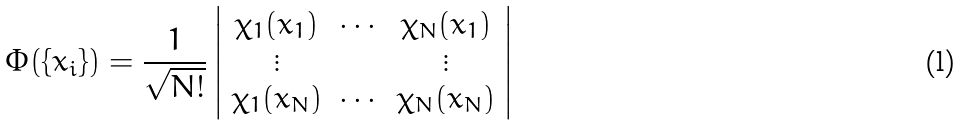<formula> <loc_0><loc_0><loc_500><loc_500>\Phi ( \{ x _ { i } \} ) = \frac { 1 } { \sqrt { N ! } } \left | \begin{array} { c c c } \chi _ { 1 } ( x _ { 1 } ) & \cdots & \chi _ { N } ( x _ { 1 } ) \\ \vdots & & \vdots \\ \chi _ { 1 } ( x _ { N } ) & \cdots & \chi _ { N } ( x _ { N } ) \end{array} \right |</formula> 